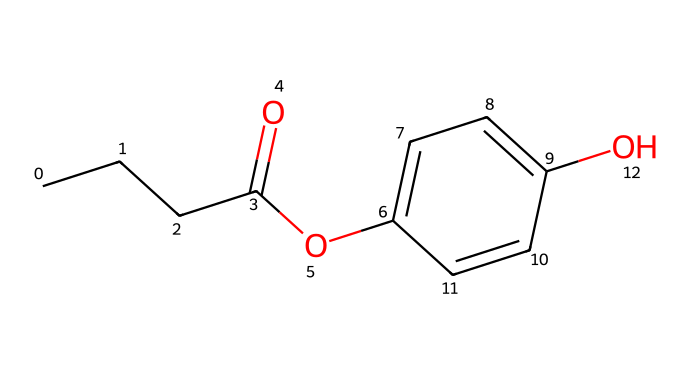What is the primary functional group present in propylparaben? The structure includes an ester functional group indicated by the C(=O)O segment, which is characteristic of parabens.
Answer: ester How many carbon atoms are present in propylparaben? Counting the carbon atoms in the chemical structure gives a total of 10 carbon atoms (C).
Answer: 10 What type of compound is propylparaben generally classified as? Propylparaben is classified as a preservative due to its ability to inhibit microbial growth in cosmetics and personal care products.
Answer: preservative Which part of the molecule contains the hydroxyl group? The -OH (hydroxyl) group is attached to the aromatic ring (specifically on the carbon ring structure), indicating its functionality in enhancing solubility and activity.
Answer: aromatic ring What indicates that propylparaben is a derivative of para-hydroxybenzoic acid? The presence of the para-positioning of the hydroxyl group in the aromatic ring (benzene) and the ester linkage to the propyl group indicates derivation from para-hydroxybenzoic acid.
Answer: para-hydroxybenzoic acid What type of bond connects the carbonyl group to the oxygen in the ester part of propylparaben? The bond connecting the carbonyl carbon to the oxygen in the ester is a covalent bond, which is formed during the esterification process.
Answer: covalent bond 